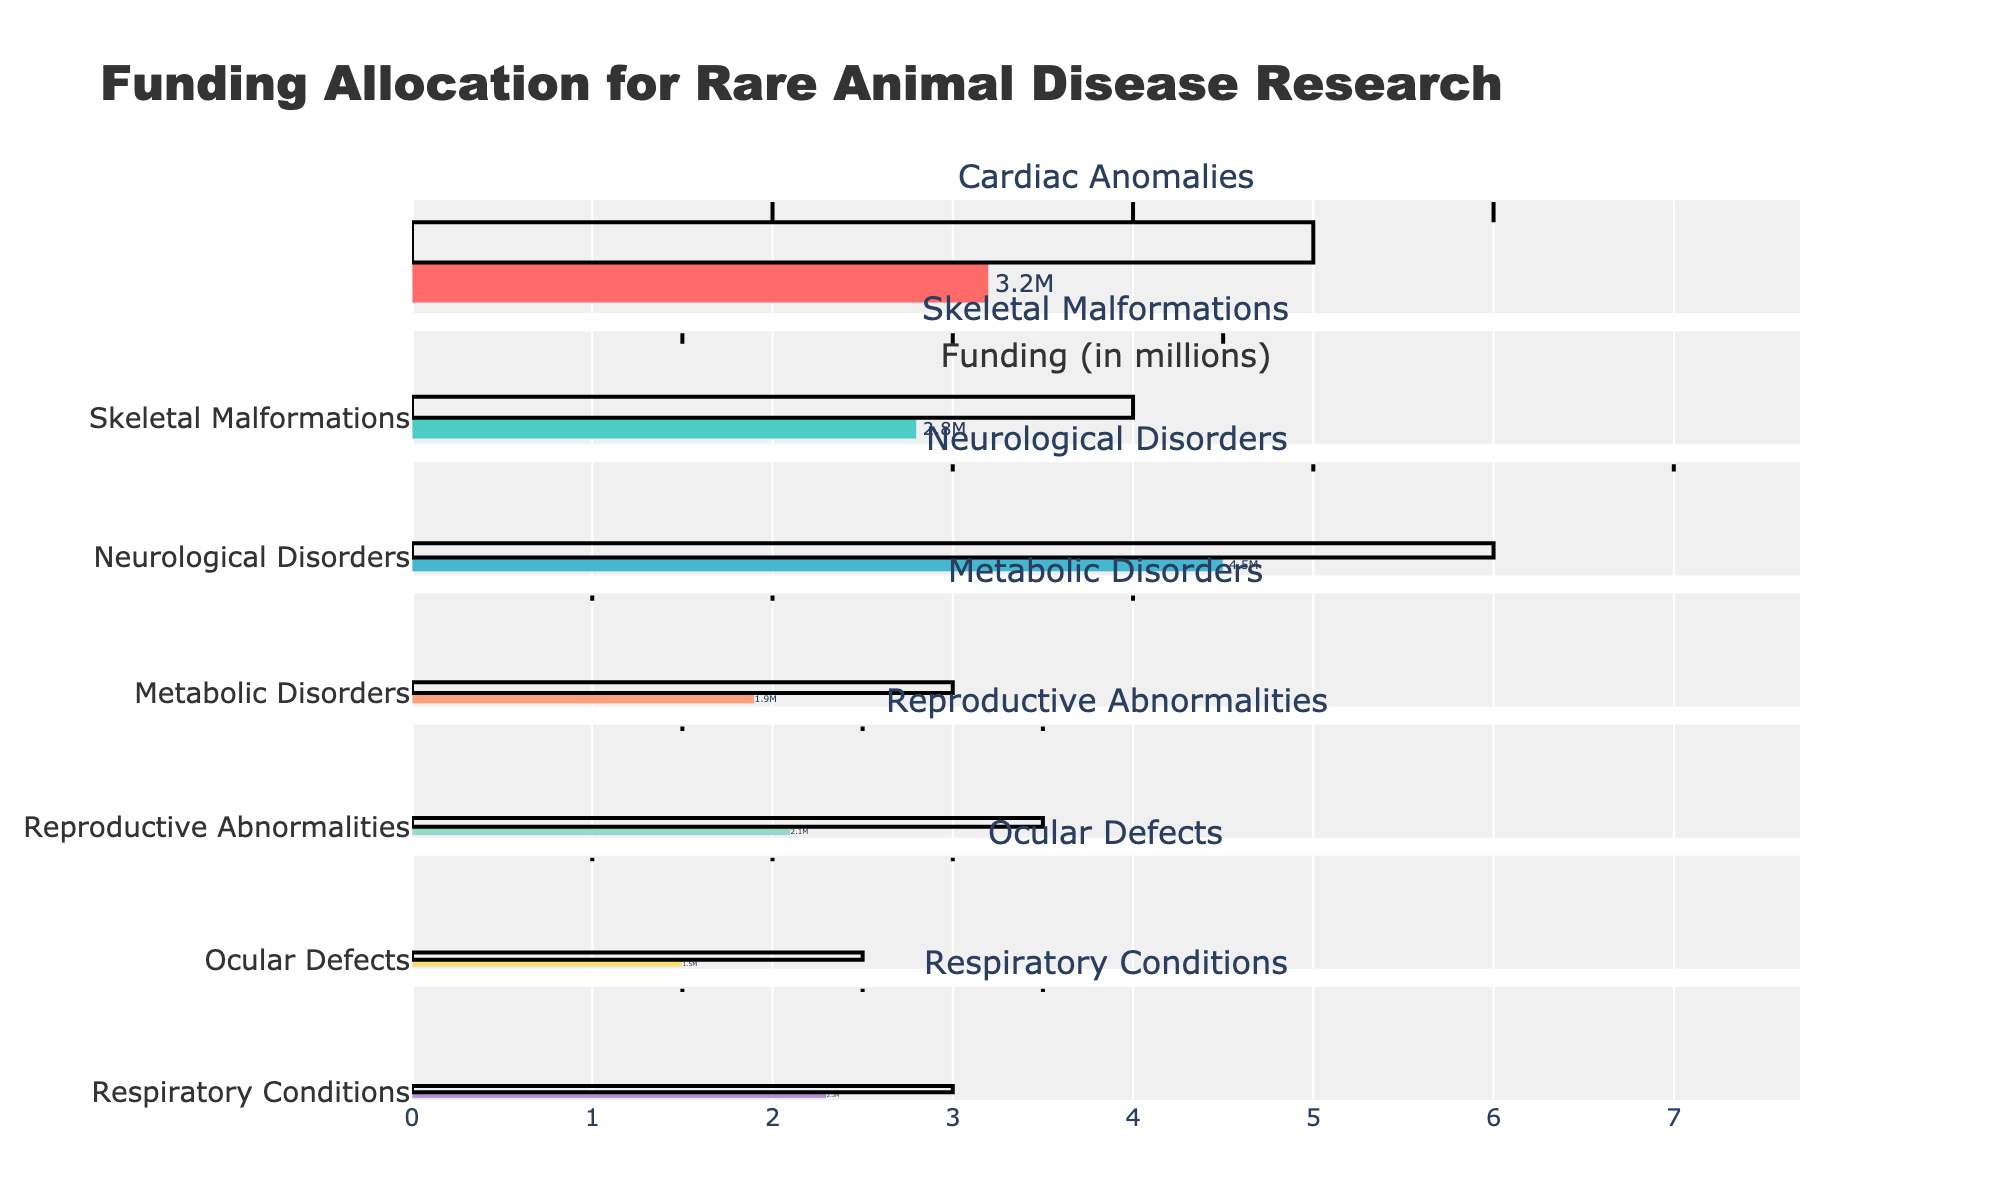Which category has the highest actual funding allocation? The highest actual funding allocation is the value represented by the longest bar among all categories. "Neurological Disorders" has an actual funding allocation of 4.5 million, which is the highest.
Answer: Neurological Disorders What is the target funding allocation for Metabolic Disorders? The target value is indicated by the dashed line. For the "Metabolic Disorders" category, the target funding allocation is 3 million.
Answer: 3 million By how much does the actual funding allocation for Cardiac Anomalies fall short of its target? The actual funding for Cardiac Anomalies is 3.2 million and the target is 5 million. The difference is calculated as 5 - 3.2.
Answer: 1.8 million Compare the actual funding allocations for Skeletal Malformations and Reproductive Abnormalities. Which one has higher funding? The actual funding for Skeletal Malformations is 2.8 million, while for Reproductive Abnormalities it is 2.1 million. Thus, Skeletal Malformations have higher funding.
Answer: Skeletal Malformations Are there any categories where actual funding exceeds the Range2 value? For each category, check if the actual funding bar extends beyond the Range2 marker. The category "Neurological Disorders" has an actual funding of 4.5 million, which exceeds its Range2 value of 5 million.
Answer: Yes, Neurological Disorders What is the total target funding allocation across all categories? Sum the target funding allocations: 5 + 4 + 6 + 3 + 3.5 + 2.5 + 3.
Answer: 27 million Among Ocular Defects and Respiratory Conditions, which has the smaller funding gap compared to its target? The gaps are calculated as follows: Ocular Defects (2.5 - 1.5) = 1 million, Respiratory Conditions (3 - 2.3) = 0.7 million. Thus, Respiratory Conditions have the smaller gap.
Answer: Respiratory Conditions Which category is closest to meeting its target funding allocation? Compare the differences between actual and target values for all categories. The smallest difference is for "Cardiac Anomalies" (5 - 3.2) = 1.8 million. Since Neurological Disorders has a smaller difference of 1.5 million (6 - 4.5), it is the closest.
Answer: Neurological Disorders 